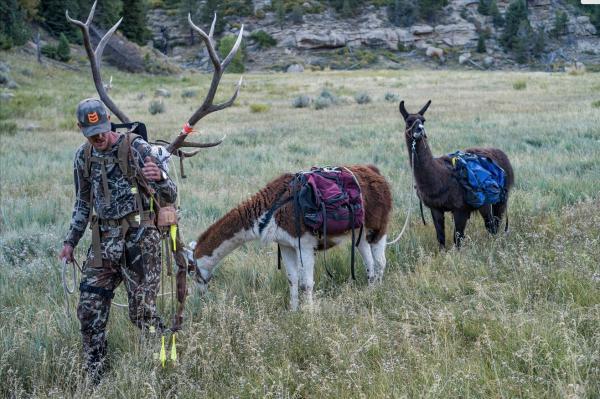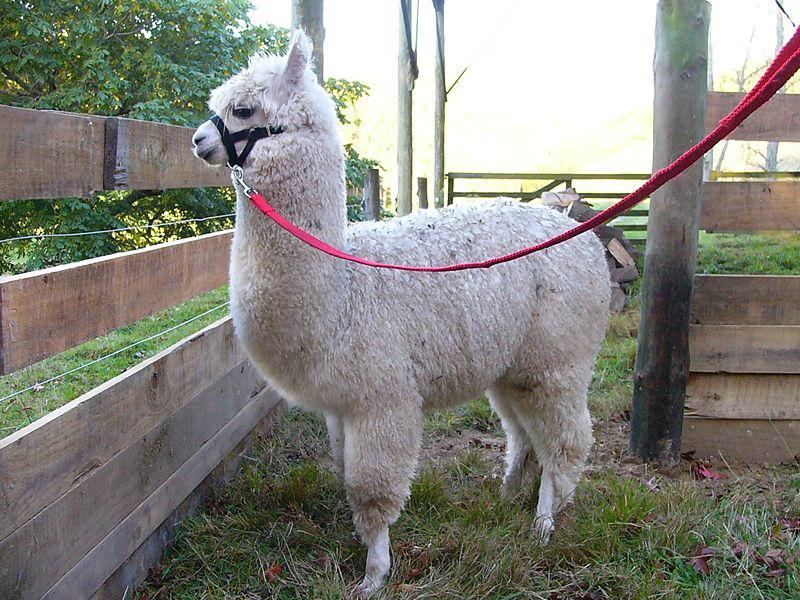The first image is the image on the left, the second image is the image on the right. Examine the images to the left and right. Is the description "In at least one image there is a hunter with deer horns and  two llames." accurate? Answer yes or no. Yes. 